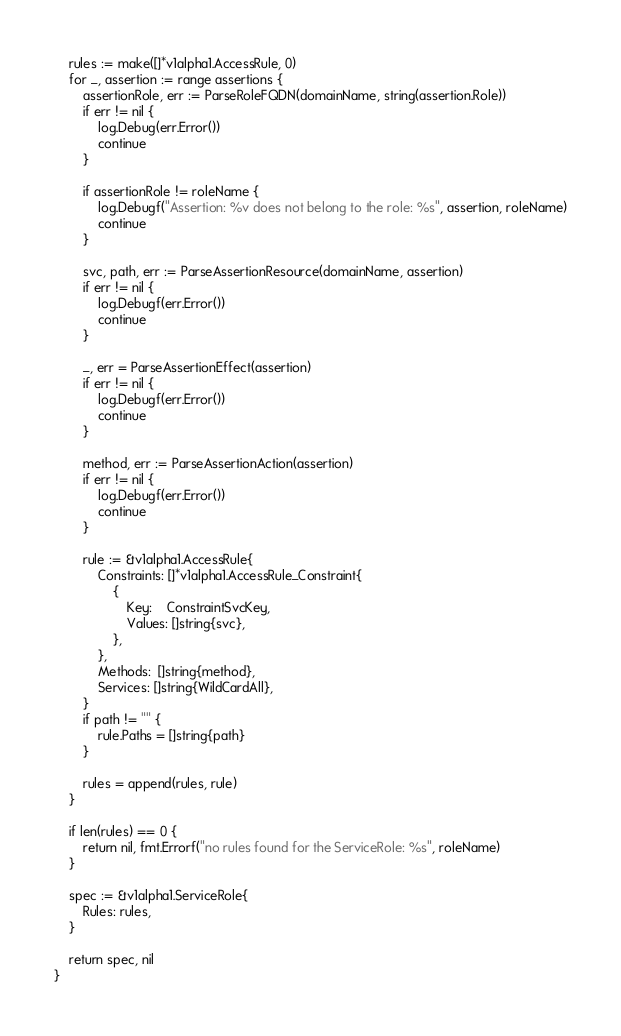Convert code to text. <code><loc_0><loc_0><loc_500><loc_500><_Go_>
	rules := make([]*v1alpha1.AccessRule, 0)
	for _, assertion := range assertions {
		assertionRole, err := ParseRoleFQDN(domainName, string(assertion.Role))
		if err != nil {
			log.Debug(err.Error())
			continue
		}

		if assertionRole != roleName {
			log.Debugf("Assertion: %v does not belong to the role: %s", assertion, roleName)
			continue
		}

		svc, path, err := ParseAssertionResource(domainName, assertion)
		if err != nil {
			log.Debugf(err.Error())
			continue
		}

		_, err = ParseAssertionEffect(assertion)
		if err != nil {
			log.Debugf(err.Error())
			continue
		}

		method, err := ParseAssertionAction(assertion)
		if err != nil {
			log.Debugf(err.Error())
			continue
		}

		rule := &v1alpha1.AccessRule{
			Constraints: []*v1alpha1.AccessRule_Constraint{
				{
					Key:    ConstraintSvcKey,
					Values: []string{svc},
				},
			},
			Methods:  []string{method},
			Services: []string{WildCardAll},
		}
		if path != "" {
			rule.Paths = []string{path}
		}

		rules = append(rules, rule)
	}

	if len(rules) == 0 {
		return nil, fmt.Errorf("no rules found for the ServiceRole: %s", roleName)
	}

	spec := &v1alpha1.ServiceRole{
		Rules: rules,
	}

	return spec, nil
}
</code> 